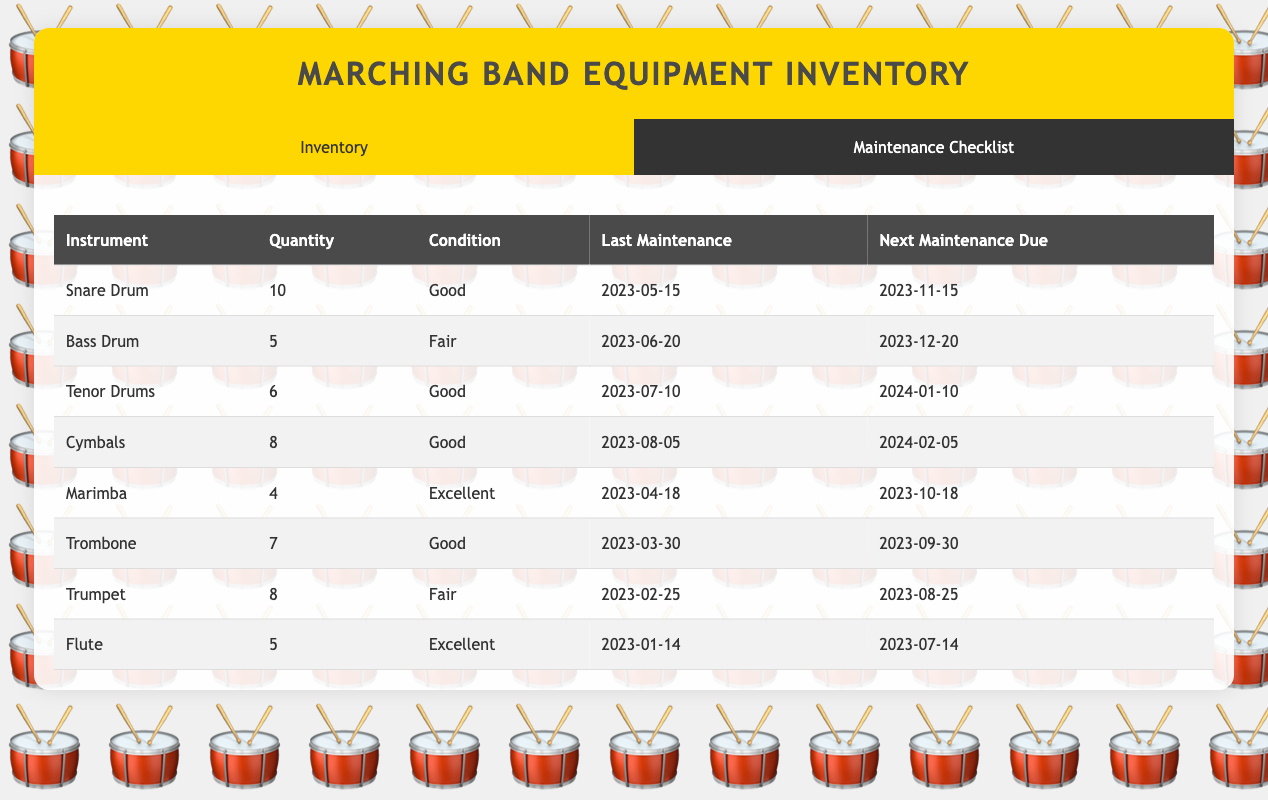What is the condition of the Bass Drum? The table states that the condition of the Bass Drum is "Fair".
Answer: Fair How many Snare Drums are there in the inventory? According to the table, there are 10 Snare Drums listed in the inventory.
Answer: 10 What is the next maintenance due date for the Trumpet? The table indicates that the next maintenance due date for the Trumpet is "2023-08-25".
Answer: 2023-08-25 Which instrument has the highest quantity in the inventory? By examining the quantities listed, the Snare Drum has the highest quantity at 10, compared to others.
Answer: Snare Drum What is the average quantity of instruments in the inventory? The total quantity of instruments is 10 + 5 + 6 + 8 + 4 + 7 + 8 + 5 = 53. There are 8 types of instruments, so the average is 53 / 8 = 6.625.
Answer: 6.625 Is the Flute in excellent condition? The table shows that the condition of the Flute is "Excellent", confirming the statement as true.
Answer: Yes How many instruments are due for maintenance this month? The instruments due for maintenance in November are the Snare Drum and Marimba. The Bass Drum is due in December, and others are later, totaling 2 instruments due this month.
Answer: 2 Which instrument requires lubrication as part of the maintenance checklist? The maintenance checklists for the Snare Drum, Trombone, and Trumpet all specify lubrication steps, confirming that multiple instruments require it.
Answer: Snare Drum, Trombone, Trumpet What are the next maintenance due dates for the instruments in "Good" condition? The Snare Drum is due on 2023-11-15, Tenor Drums on 2024-01-10, and Trombone is due on 2023-09-30, confirming all due dates for the "Good" condition instruments.
Answer: 2023-11-15, 2024-01-10, 2023-09-30 